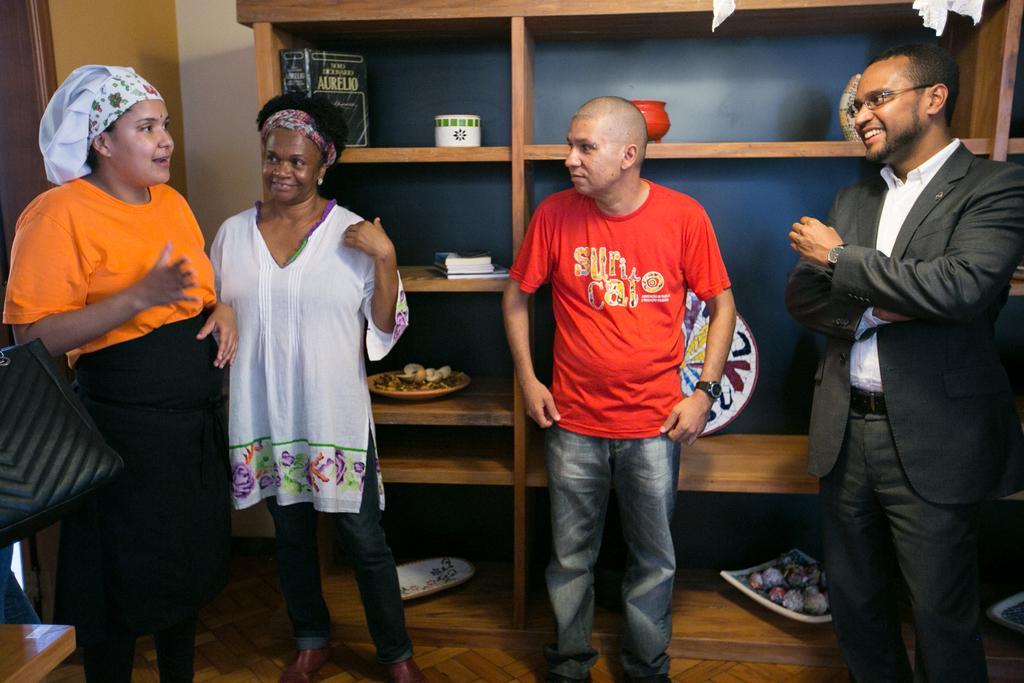How many people are in the image? There are four persons in the image. What are the persons wearing? The persons are wearing clothes. What can be seen behind the persons? The persons are standing in front of a rack. Can you describe the person on the left side of the image? The person on the left side of the image is wearing a cap. What type of cloud can be seen in the image? There are no clouds present in the image. Can you tell me how the person on the right side of the image is using their skate? There is no skate present in the image. 